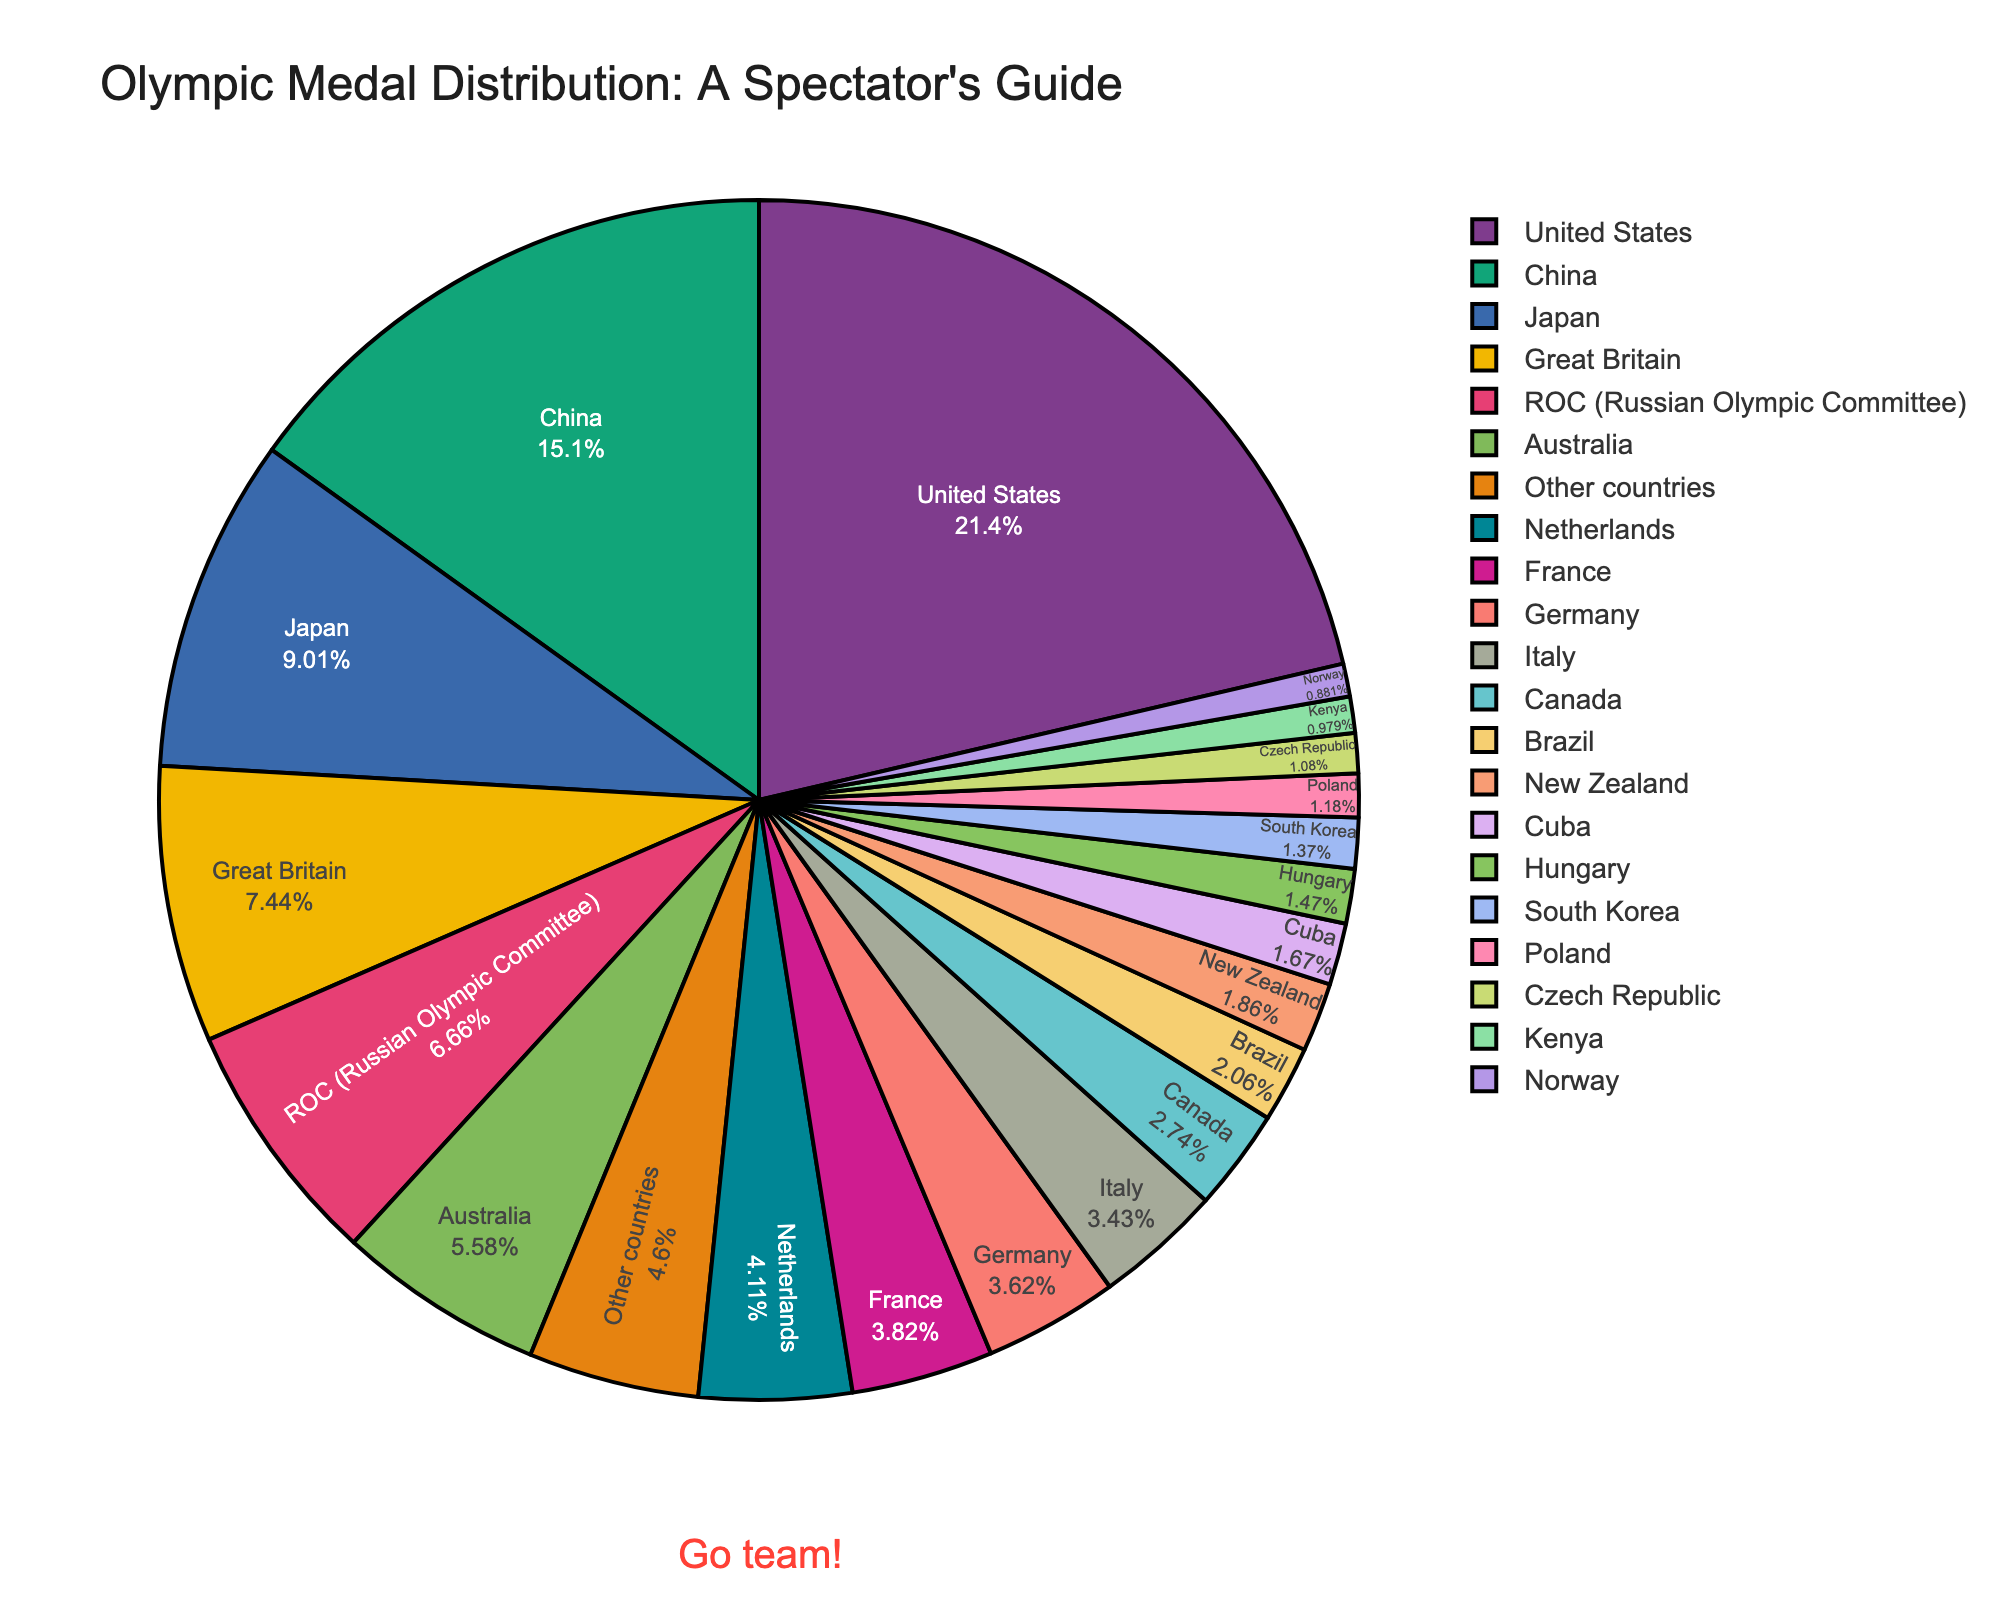What is the percentage of medals won by the United States? Look at the pie section labeled "United States" and read the value associated with it.
Answer: 21.8% Which two countries combined have a total medal percentage greater than that of China? The medal percentage of China is 15.4%. Summing the percentages of several pairs, we find that the United States (21.8%) combined with any other country already surpasses China's percentage.
Answer: United States and any other country Which country has the smallest percentage of medals, and what is that percentage? Locate the smallest segment in the pie chart and read the percentage.
Answer: Norway, 0.9% Compare the combined percentage of medals won by Japan and Australia with that of the United States. Which is greater? The combined medal percentage of Japan (9.2%) and Australia (5.7%) is 14.9%. The United States has a medal percentage of 21.8%. Therefore, the United States has a greater percentage.
Answer: United States What percentage of medals do other countries account for? Find the segment labeled "Other countries" and read the percentage.
Answer: 4.7% Which country has a percentage closest to 4.0%? Find the segment with a percentage closest to 4.0%. France has 3.9%, which is closest to 4.0%.
Answer: France Are there more medals won collectively by the ROC (Russian Olympic Committee) and Netherlands, or by Great Britain alone? The ROC has 6.8% and the Netherlands 4.2%, for a total of 11.0%. Great Britain alone has 7.6%. 11.0% is greater than 7.6%.
Answer: ROC and Netherlands What is the total medal percentage of the top three countries combined? The top three countries are the United States (21.8%), China (15.4%), and Japan (9.2%). Adding these together, 21.8% + 15.4% + 9.2% = 46.4%.
Answer: 46.4% Which two countries have closest medal percentages? Look for segments with similar sizes. Germany (3.7%) and Italy (3.5%) have close percentages.
Answer: Germany and Italy What color represents Brazil in the pie chart? Locate the segment labeled "Brazil" and identify its color. This could vary based on the color palette, but typically a unique color will be used.
Answer: (depends on rendition of chart, e.g., "orange") 